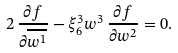<formula> <loc_0><loc_0><loc_500><loc_500>2 \, \frac { \partial f } { \partial \overline { w ^ { 1 } } } - \xi ^ { 3 } _ { 6 } w ^ { 3 } \, \frac { \partial f } { \partial { w ^ { 2 } } } = 0 .</formula> 